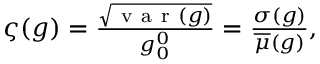Convert formula to latex. <formula><loc_0><loc_0><loc_500><loc_500>\begin{array} { r } { \varsigma ( g ) = \frac { \sqrt { v a r ( g ) } } { g _ { 0 } ^ { 0 } } = \frac { \sigma ( g ) } { \overline { \mu } ( g ) } , } \end{array}</formula> 